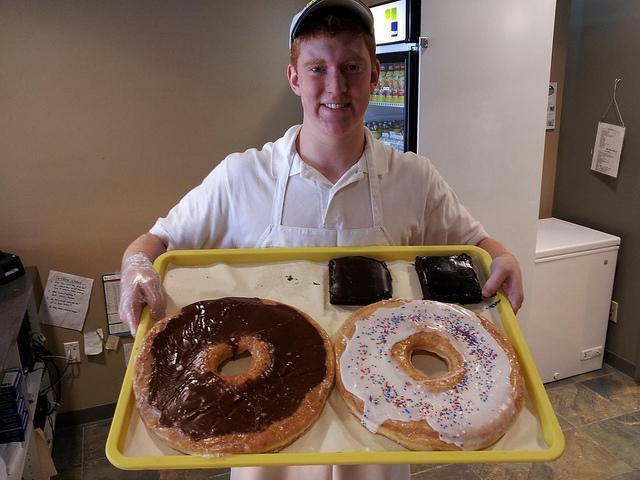How many donuts are in the picture?
Give a very brief answer. 3. How many refrigerators can you see?
Give a very brief answer. 2. 